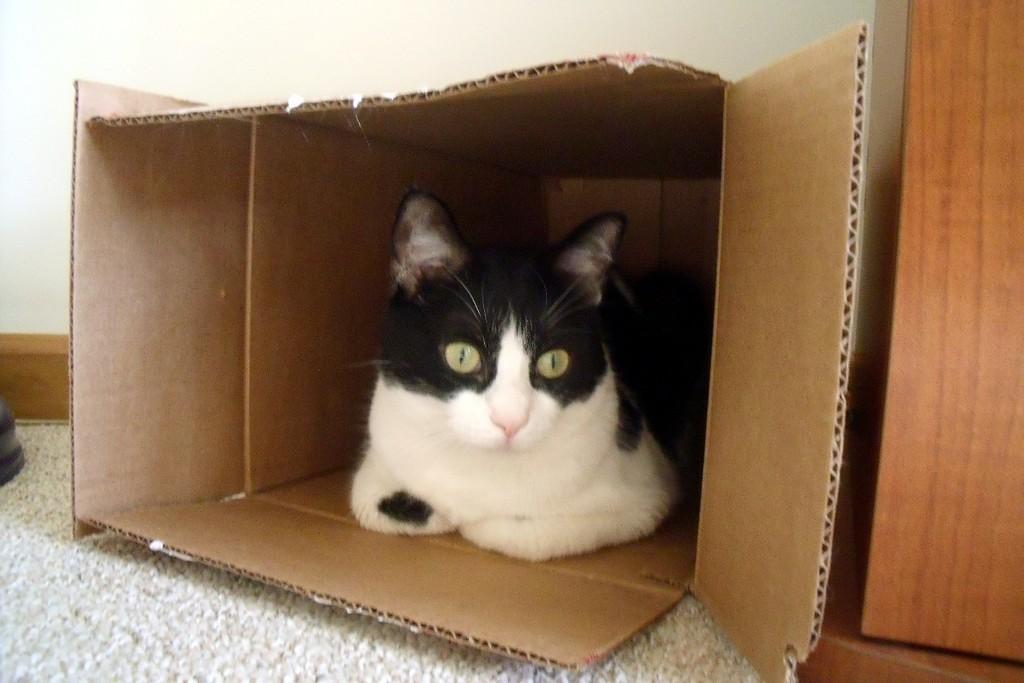Describe this image in one or two sentences. In this image I can see a cat is sitting in the card board box. 